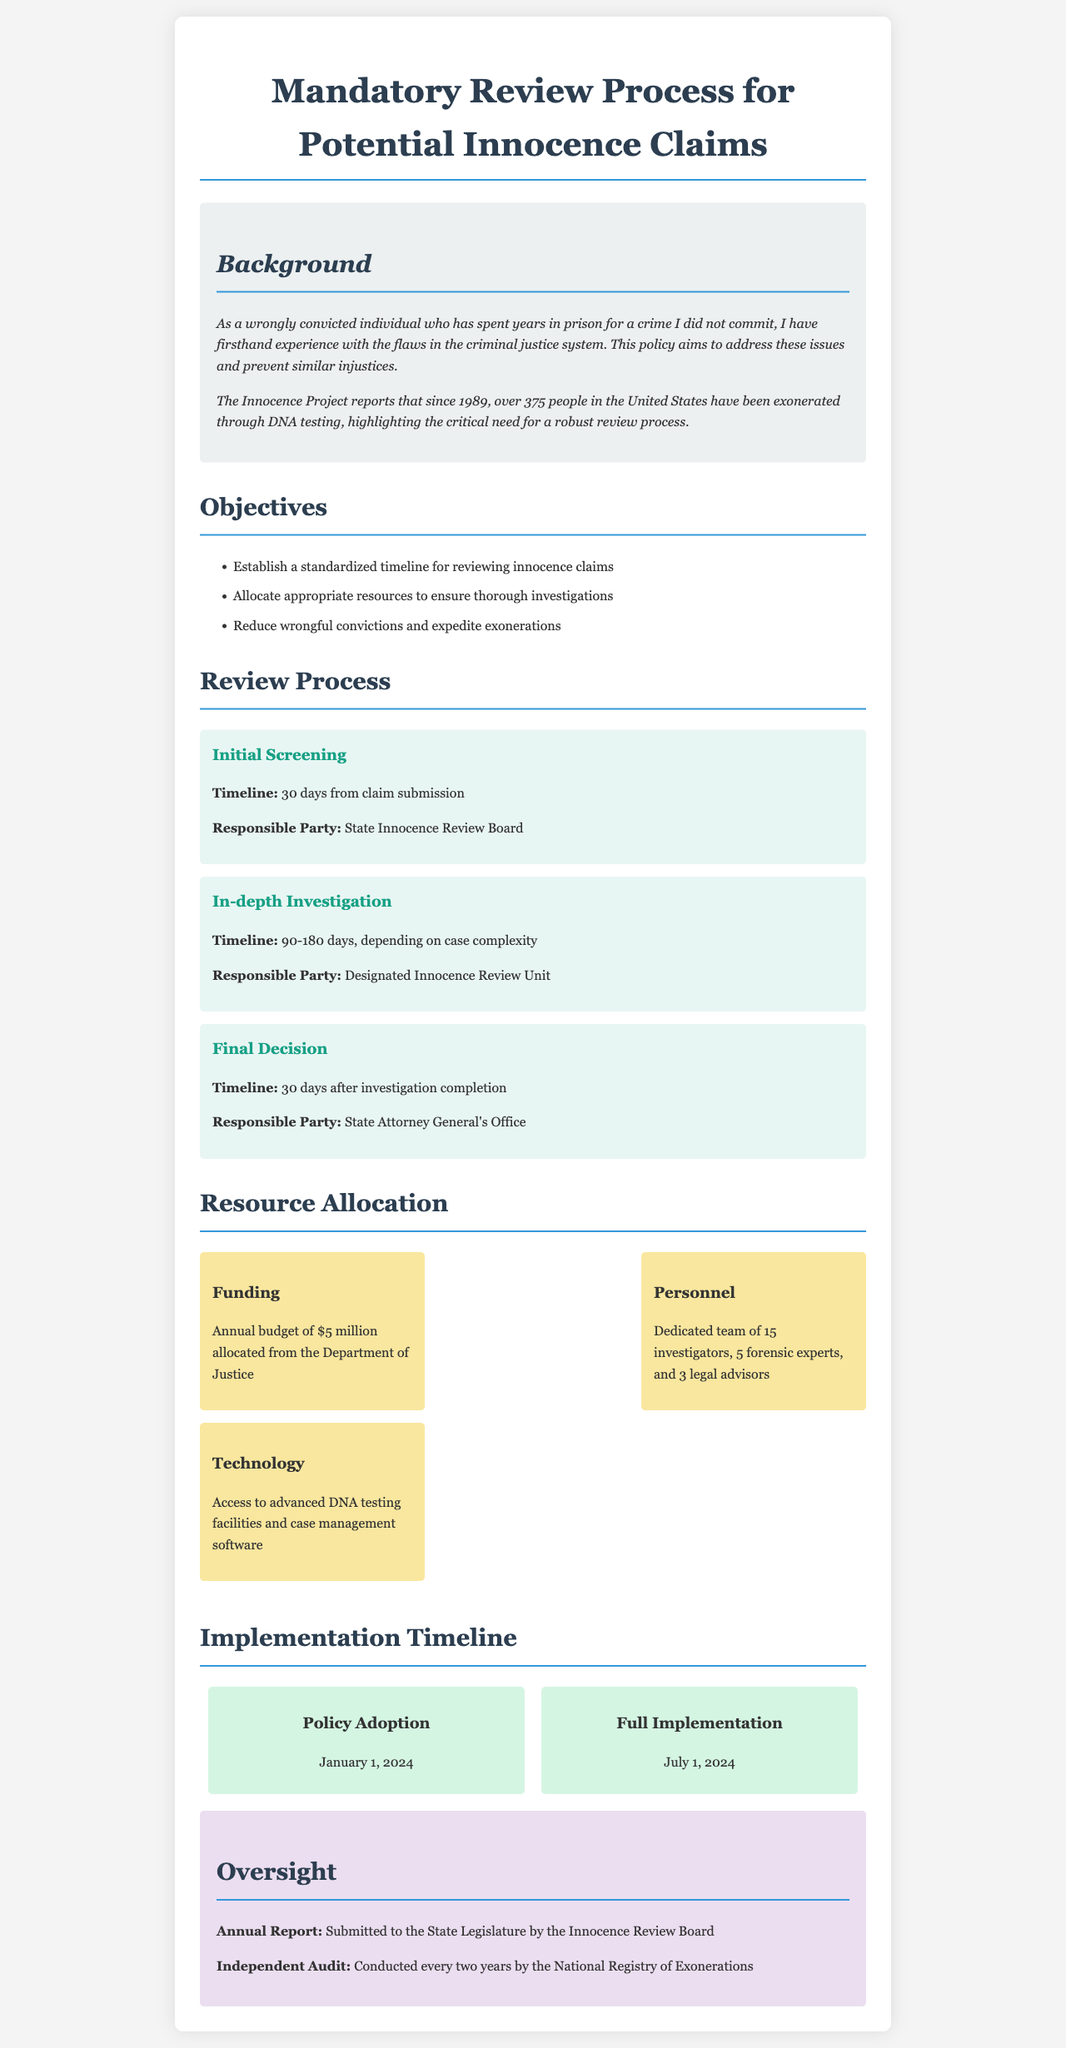What is the total annual budget allocated for the review process? The total annual budget for the review process, as stated in the document, is $5 million.
Answer: $5 million Who is responsible for the final decision after the investigation? The document specifies that the State Attorney General's Office is responsible for the final decision.
Answer: State Attorney General's Office What is the timeline for the initial screening of innocence claims? According to the document, the timeline for the initial screening is 30 days from claim submission.
Answer: 30 days When will the policy be fully implemented? The document indicates that full implementation of the policy will be on July 1, 2024.
Answer: July 1, 2024 How many investigators are allocated to the review process? The document states that there is a dedicated team of 15 investigators for the innocence claims review process.
Answer: 15 What is the purpose of the annual report mentioned in the document? The annual report is submitted to the State Legislature by the Innocence Review Board, focusing on oversight.
Answer: Oversight What additional technology is provided for the innocence review process? The document mentions access to advanced DNA testing facilities and case management software as the technology provided.
Answer: Advanced DNA testing facilities and case management software What is the timeline for the in-depth investigation? The document outlines that the timeline for the in-depth investigation is between 90 to 180 days, depending on case complexity.
Answer: 90-180 days What is the main objective of this policy document? The main objective is to reduce wrongful convictions and expedite exonerations.
Answer: Reduce wrongful convictions and expedite exonerations 